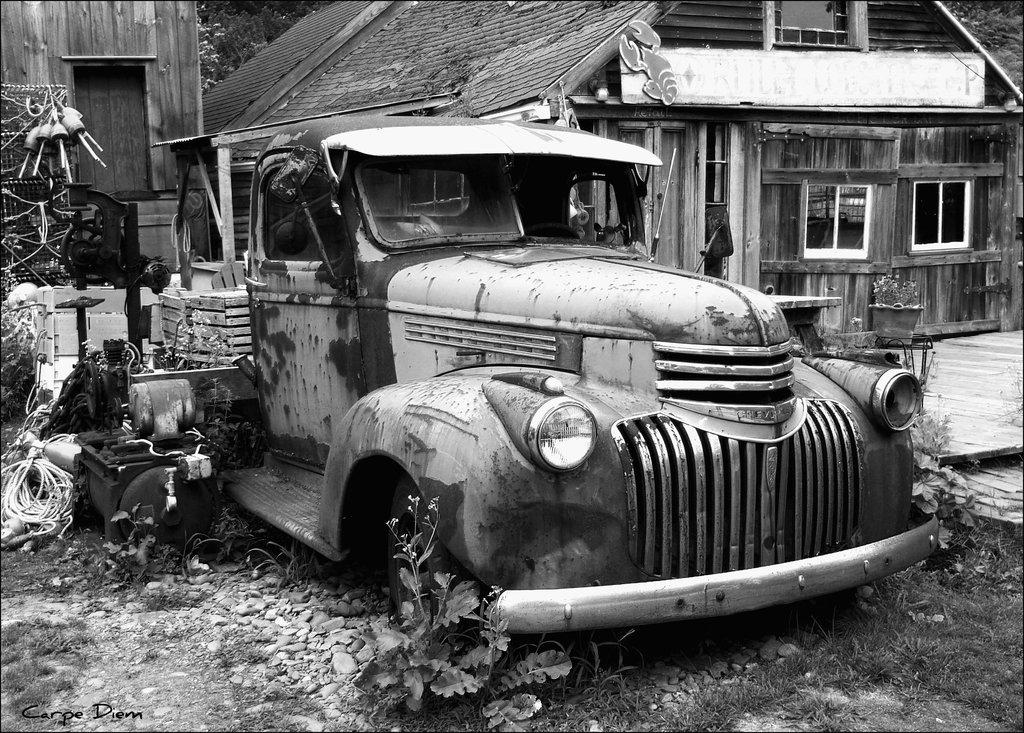What is the color scheme of the image? The image is black and white. What type of house is in the image? There is a wooden house in the image. What is located in front of the house? There is a damaged vehicle in front of the house. What can be seen behind the vehicle? There are objects behind the vehicle. What type of advice can be seen written on the house in the image? There is no advice written on the house in the image, as it is a black and white photograph. What type of comb is visible in the image? There is no comb present in the image. 